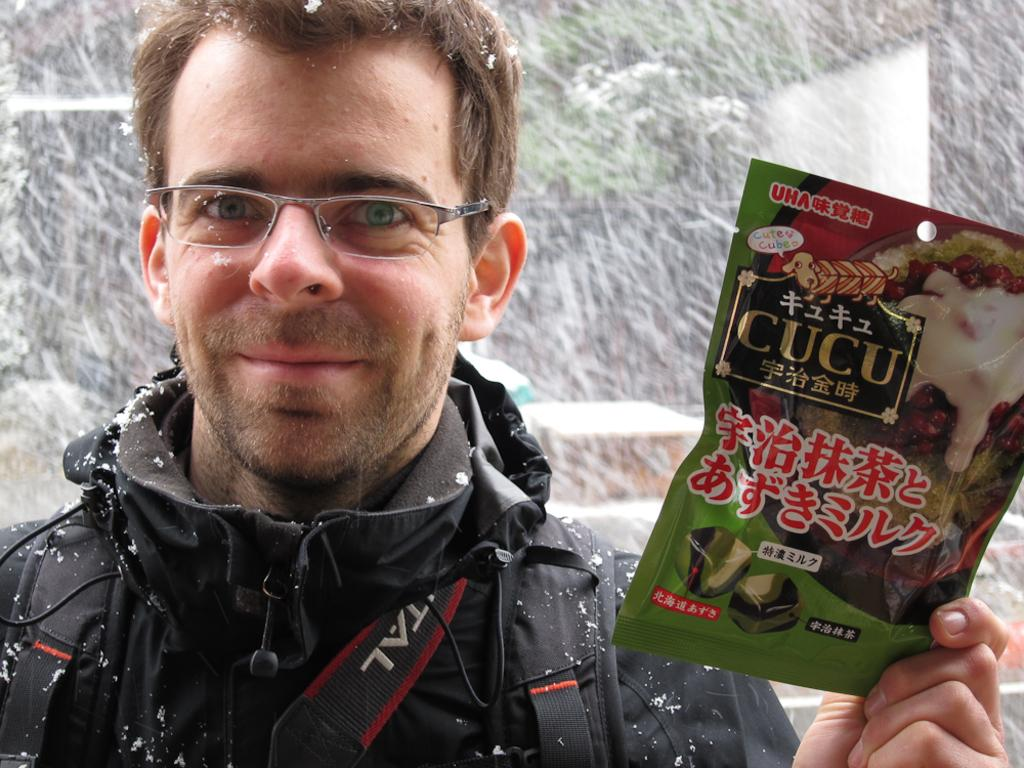Who is present in the image? There is a man in the image. What can be observed about the man's appearance? The man is wearing glasses. What is the man holding in the image? The man is holding a cover labeled as 'CUCU'. What is the weather condition in the background of the image? There is snowfall in the background of the image. How many houses are visible in the image? There are no houses visible in the image; it features a man holding a cover and snowfall in the background. What type of twig is the man using to read the label on the cover? There is no twig present in the image; the man is simply holding the cover labeled 'CUCU'. 